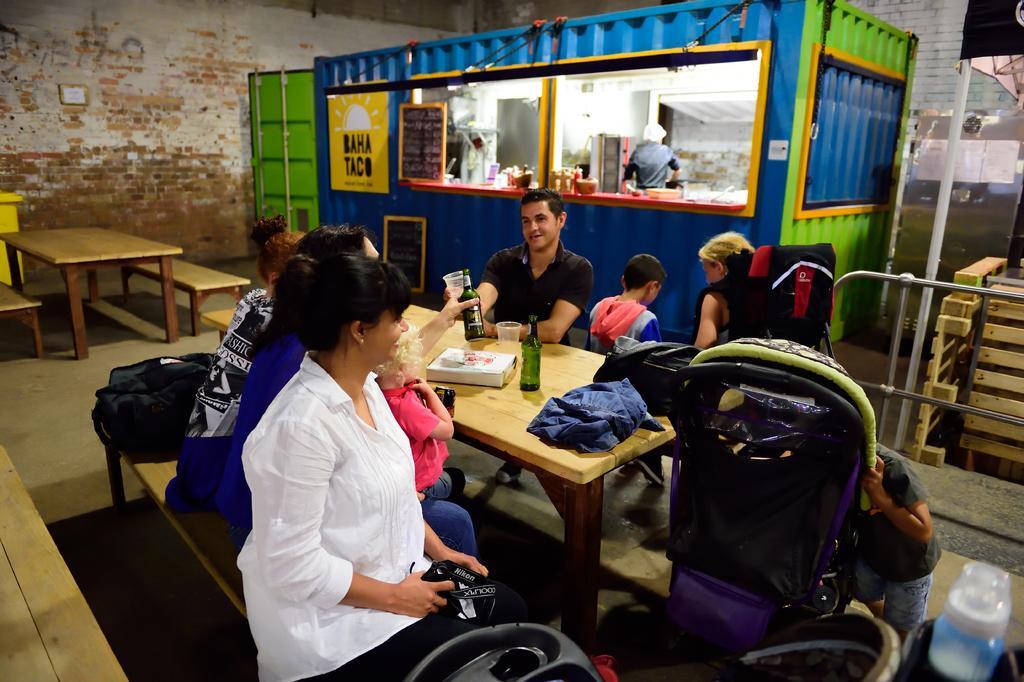Can you describe this image briefly? In this image I see few people sitting and there are 2 tables over here and on this table I see few things on it. In the background I see the wall, a shop and a person in it. 